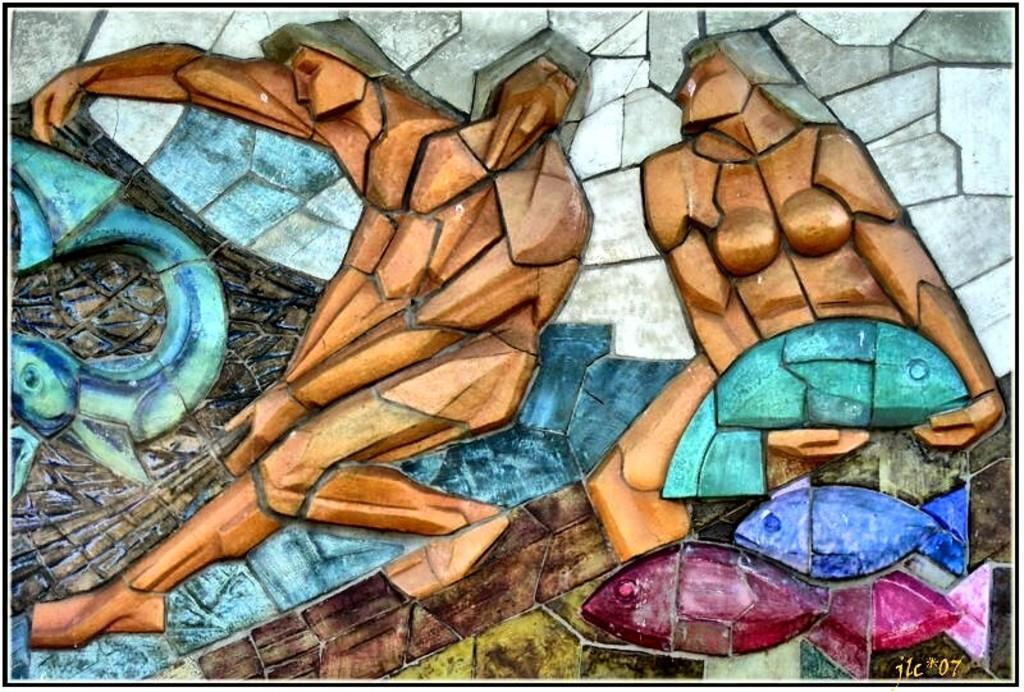What is hanging on the wall in the image? There is a painting on the wall in the image. What is the subject matter of the painting? The painting depicts three persons and fishes. Where is the drawer located in the image? There is no drawer present in the image. What type of bridge can be seen connecting the three persons in the painting? The painting does not depict a bridge connecting the three persons; it only shows them and the fishes. 